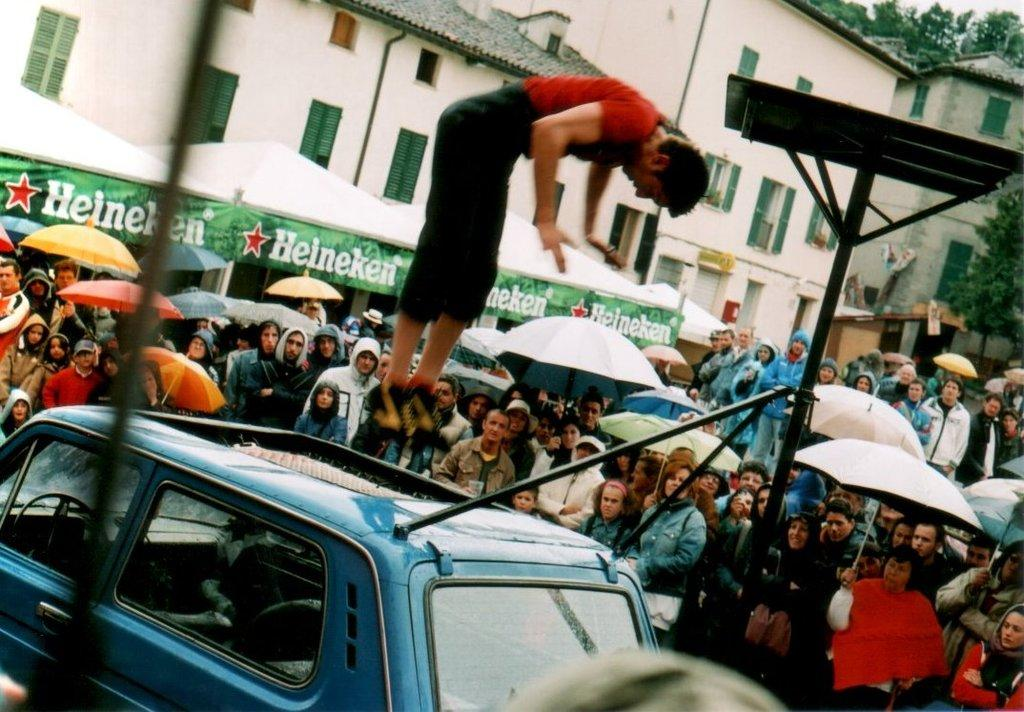Provide a one-sentence caption for the provided image. Person flipping on a car in front of a sign that says "Heineken". 